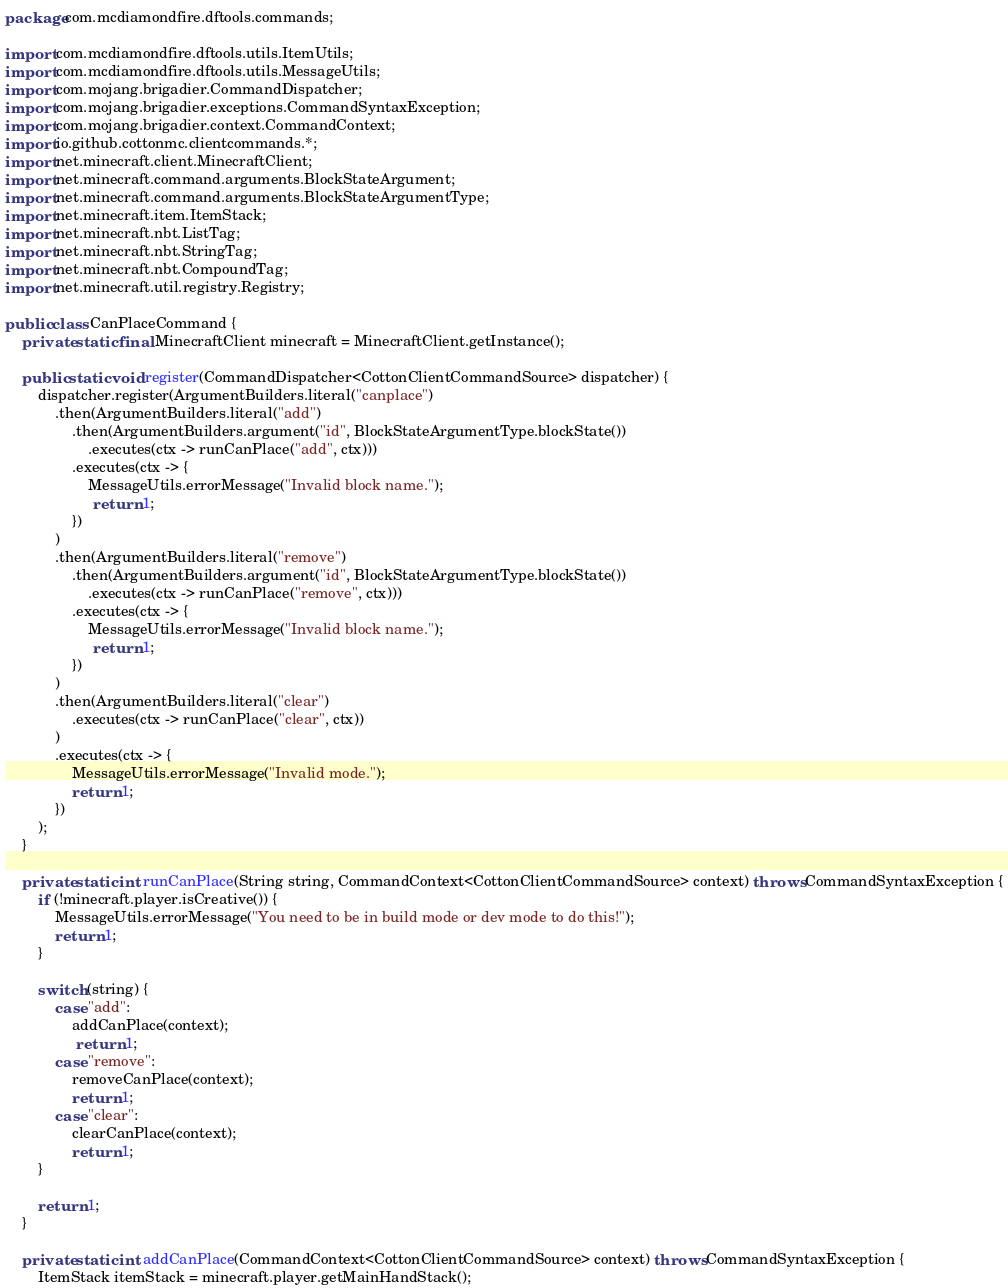Convert code to text. <code><loc_0><loc_0><loc_500><loc_500><_Java_>package com.mcdiamondfire.dftools.commands;

import com.mcdiamondfire.dftools.utils.ItemUtils;
import com.mcdiamondfire.dftools.utils.MessageUtils;
import com.mojang.brigadier.CommandDispatcher;
import com.mojang.brigadier.exceptions.CommandSyntaxException;
import com.mojang.brigadier.context.CommandContext;
import io.github.cottonmc.clientcommands.*;
import net.minecraft.client.MinecraftClient;
import net.minecraft.command.arguments.BlockStateArgument;
import net.minecraft.command.arguments.BlockStateArgumentType;
import net.minecraft.item.ItemStack;
import net.minecraft.nbt.ListTag;
import net.minecraft.nbt.StringTag;
import net.minecraft.nbt.CompoundTag;
import net.minecraft.util.registry.Registry;

public class CanPlaceCommand {
    private static final MinecraftClient minecraft = MinecraftClient.getInstance();

    public static void register(CommandDispatcher<CottonClientCommandSource> dispatcher) {
        dispatcher.register(ArgumentBuilders.literal("canplace")
            .then(ArgumentBuilders.literal("add")
                .then(ArgumentBuilders.argument("id", BlockStateArgumentType.blockState())
                    .executes(ctx -> runCanPlace("add", ctx)))
                .executes(ctx -> {
                    MessageUtils.errorMessage("Invalid block name.");
                     return 1;
                })
            )
            .then(ArgumentBuilders.literal("remove")
                .then(ArgumentBuilders.argument("id", BlockStateArgumentType.blockState())
                    .executes(ctx -> runCanPlace("remove", ctx)))
                .executes(ctx -> {
                    MessageUtils.errorMessage("Invalid block name.");
                     return 1;
                })
            )
            .then(ArgumentBuilders.literal("clear")
                .executes(ctx -> runCanPlace("clear", ctx))
            )
            .executes(ctx -> {
                MessageUtils.errorMessage("Invalid mode.");
                return 1;
            })
        );
    }
    
    private static int runCanPlace(String string, CommandContext<CottonClientCommandSource> context) throws CommandSyntaxException {
        if (!minecraft.player.isCreative()) {
			MessageUtils.errorMessage("You need to be in build mode or dev mode to do this!");
			return 1;
        }

        switch (string) {
            case "add":
                addCanPlace(context);
                 return 1;
            case "remove":
                removeCanPlace(context);
                return 1;
            case "clear":
                clearCanPlace(context);
                return 1;
        }

        return 1;
    }

    private static int addCanPlace(CommandContext<CottonClientCommandSource> context) throws CommandSyntaxException {
        ItemStack itemStack = minecraft.player.getMainHandStack();
</code> 